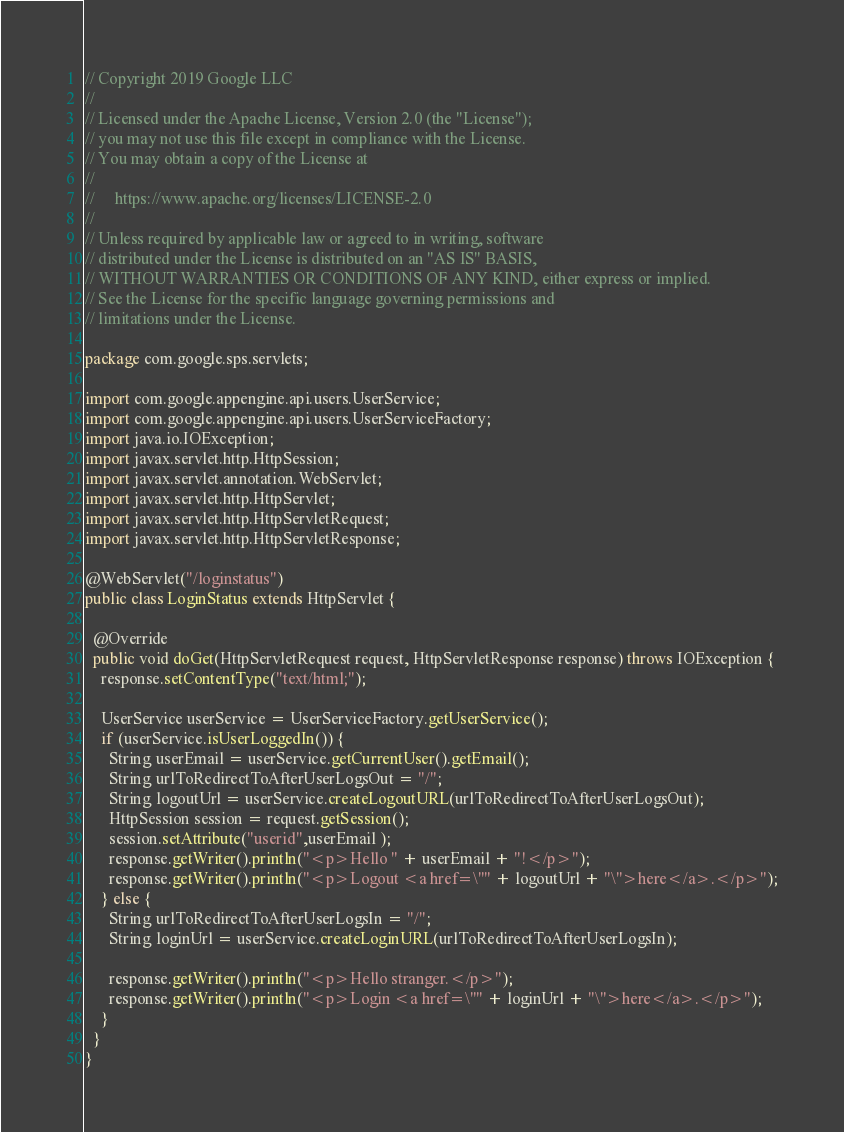Convert code to text. <code><loc_0><loc_0><loc_500><loc_500><_Java_>// Copyright 2019 Google LLC
//
// Licensed under the Apache License, Version 2.0 (the "License");
// you may not use this file except in compliance with the License.
// You may obtain a copy of the License at
//
//     https://www.apache.org/licenses/LICENSE-2.0
//
// Unless required by applicable law or agreed to in writing, software
// distributed under the License is distributed on an "AS IS" BASIS,
// WITHOUT WARRANTIES OR CONDITIONS OF ANY KIND, either express or implied.
// See the License for the specific language governing permissions and
// limitations under the License.

package com.google.sps.servlets;

import com.google.appengine.api.users.UserService;
import com.google.appengine.api.users.UserServiceFactory;
import java.io.IOException;
import javax.servlet.http.HttpSession;
import javax.servlet.annotation.WebServlet;
import javax.servlet.http.HttpServlet;
import javax.servlet.http.HttpServletRequest;
import javax.servlet.http.HttpServletResponse;

@WebServlet("/loginstatus")
public class LoginStatus extends HttpServlet {

  @Override
  public void doGet(HttpServletRequest request, HttpServletResponse response) throws IOException {
    response.setContentType("text/html;");

    UserService userService = UserServiceFactory.getUserService();
    if (userService.isUserLoggedIn()) {
      String userEmail = userService.getCurrentUser().getEmail();
      String urlToRedirectToAfterUserLogsOut = "/";
      String logoutUrl = userService.createLogoutURL(urlToRedirectToAfterUserLogsOut);
      HttpSession session = request.getSession();
      session.setAttribute("userid",userEmail );
      response.getWriter().println("<p>Hello " + userEmail + "!</p>");
      response.getWriter().println("<p>Logout <a href=\"" + logoutUrl + "\">here</a>.</p>");
    } else {
      String urlToRedirectToAfterUserLogsIn = "/";
      String loginUrl = userService.createLoginURL(urlToRedirectToAfterUserLogsIn);

      response.getWriter().println("<p>Hello stranger.</p>");
      response.getWriter().println("<p>Login <a href=\"" + loginUrl + "\">here</a>.</p>");
    }
  }
}</code> 